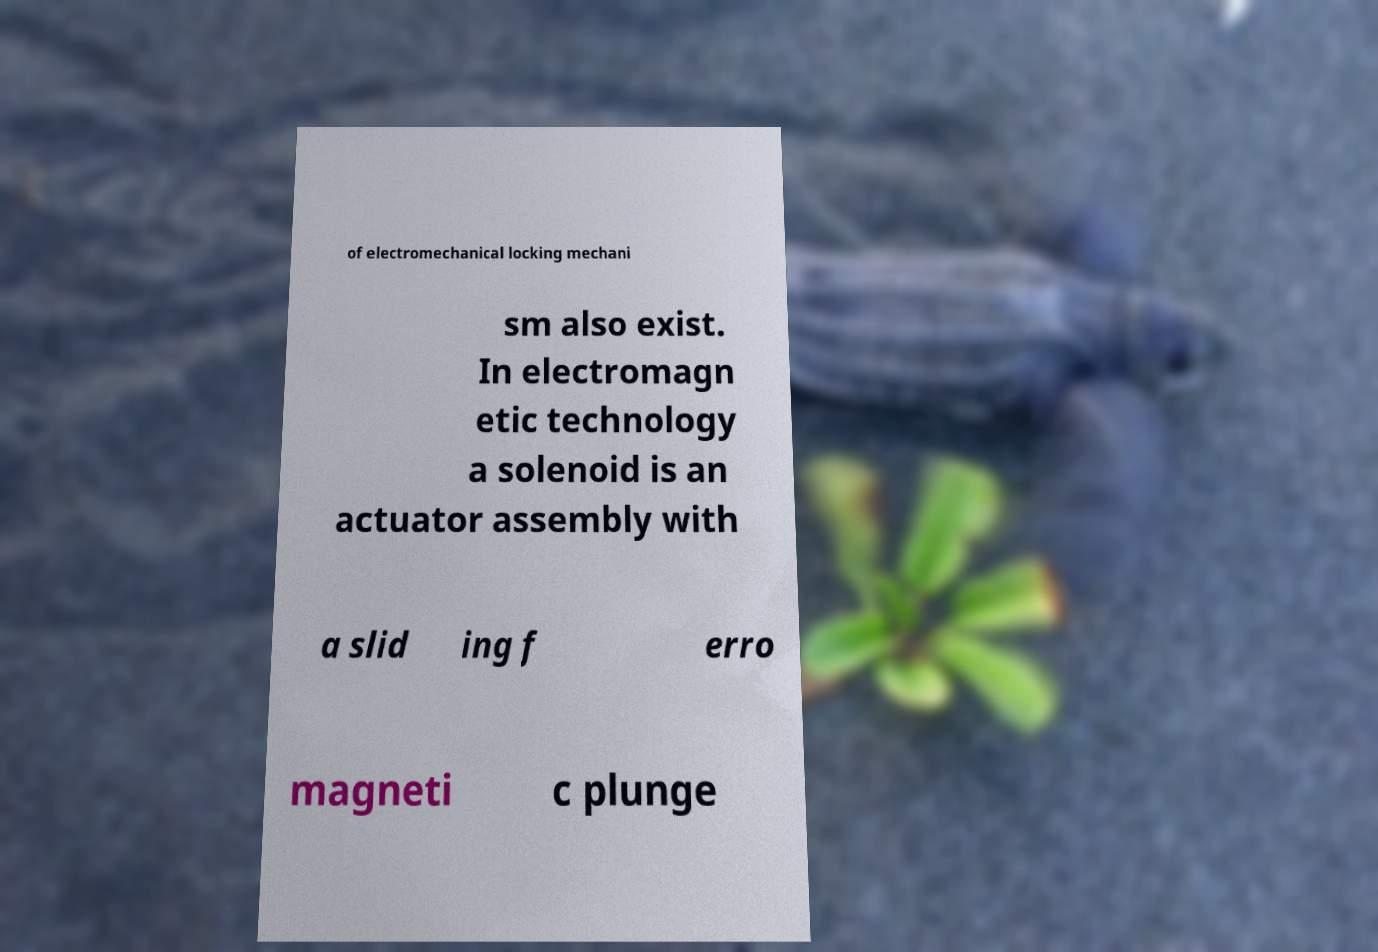Could you assist in decoding the text presented in this image and type it out clearly? of electromechanical locking mechani sm also exist. In electromagn etic technology a solenoid is an actuator assembly with a slid ing f erro magneti c plunge 